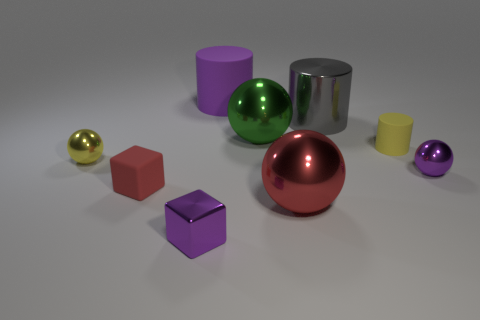Add 1 small metal objects. How many objects exist? 10 Subtract all cubes. How many objects are left? 7 Subtract 0 cyan spheres. How many objects are left? 9 Subtract all tiny shiny spheres. Subtract all gray metallic cylinders. How many objects are left? 6 Add 8 large cylinders. How many large cylinders are left? 10 Add 7 large cylinders. How many large cylinders exist? 9 